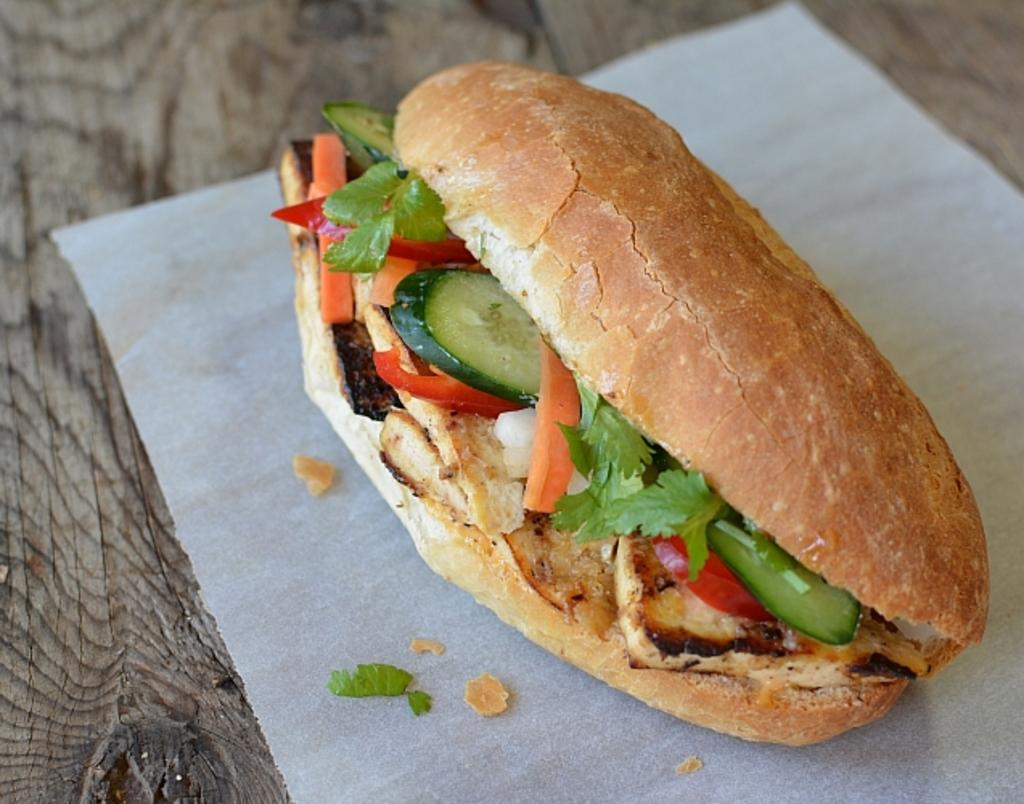What is the main subject of the image? The main subject of the image is a stuffed burger. How is the stuffed burger positioned in the image? The stuffed burger is placed on a paper napkin. What type of pancake is causing anger in the image? There is no pancake or indication of anger present in the image; it features a stuffed burger placed on a paper napkin. 